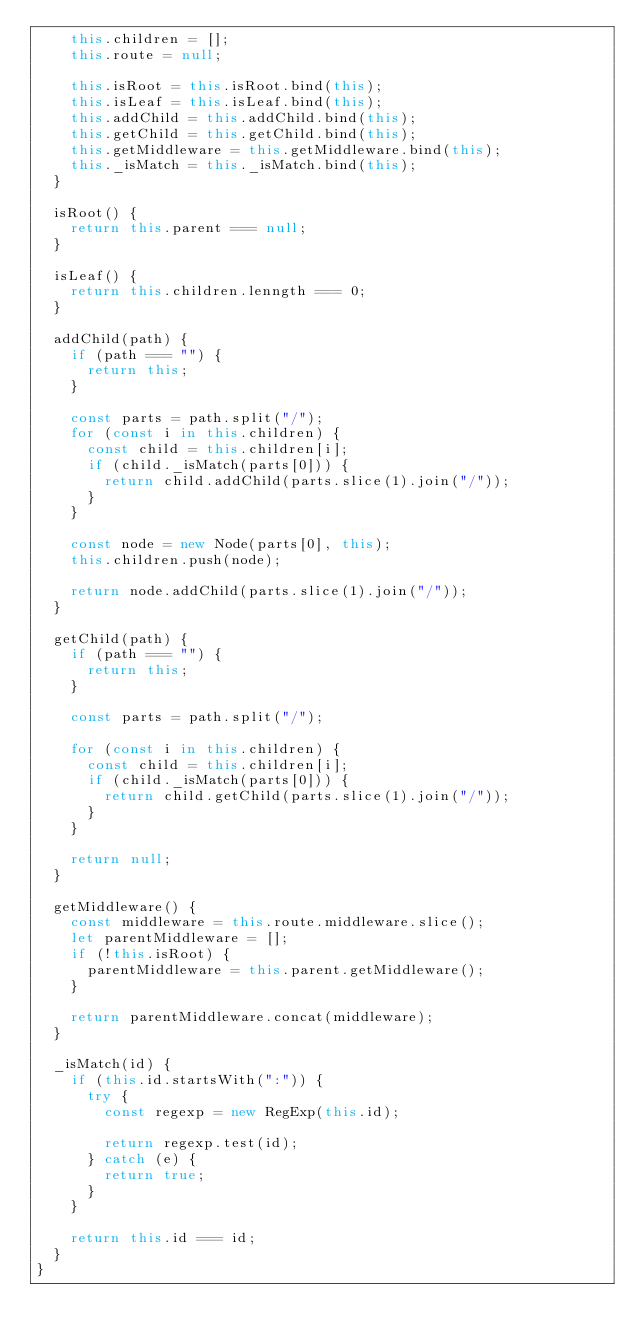Convert code to text. <code><loc_0><loc_0><loc_500><loc_500><_JavaScript_>    this.children = [];
    this.route = null;

    this.isRoot = this.isRoot.bind(this);
    this.isLeaf = this.isLeaf.bind(this);
    this.addChild = this.addChild.bind(this);
    this.getChild = this.getChild.bind(this);
    this.getMiddleware = this.getMiddleware.bind(this);
    this._isMatch = this._isMatch.bind(this);
  }

  isRoot() {
    return this.parent === null;
  }

  isLeaf() {
    return this.children.lenngth === 0;
  }

  addChild(path) {
    if (path === "") {
      return this;
    }

    const parts = path.split("/");
    for (const i in this.children) {
      const child = this.children[i];
      if (child._isMatch(parts[0])) {
        return child.addChild(parts.slice(1).join("/"));
      }
    }

    const node = new Node(parts[0], this);
    this.children.push(node);

    return node.addChild(parts.slice(1).join("/"));
  }

  getChild(path) {
    if (path === "") {
      return this;
    }

    const parts = path.split("/");

    for (const i in this.children) {
      const child = this.children[i];
      if (child._isMatch(parts[0])) {
        return child.getChild(parts.slice(1).join("/"));
      }
    }

    return null;
  }

  getMiddleware() {
    const middleware = this.route.middleware.slice();
    let parentMiddleware = [];
    if (!this.isRoot) {
      parentMiddleware = this.parent.getMiddleware();
    }

    return parentMiddleware.concat(middleware);
  }

  _isMatch(id) {
    if (this.id.startsWith(":")) {
      try {
        const regexp = new RegExp(this.id);

        return regexp.test(id);
      } catch (e) {
        return true;
      }
    }

    return this.id === id;
  }
}
</code> 